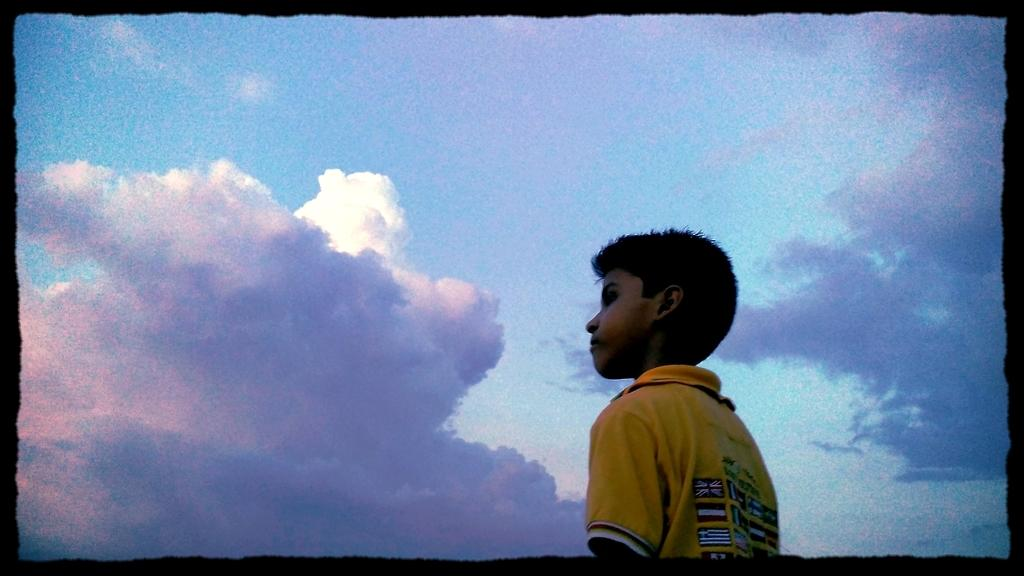What is the main subject in the foreground of the image? There is a boy in the foreground of the image. What is the boy wearing? The boy is wearing a yellow t-shirt. What can be seen in the background of the image? The sky is visible in the background of the image. What is the color of the border around the image? The image has a black border. Where is the mine located in the image? There is no mine present in the image. What type of rail is visible in the image? There is no rail present in the image. 